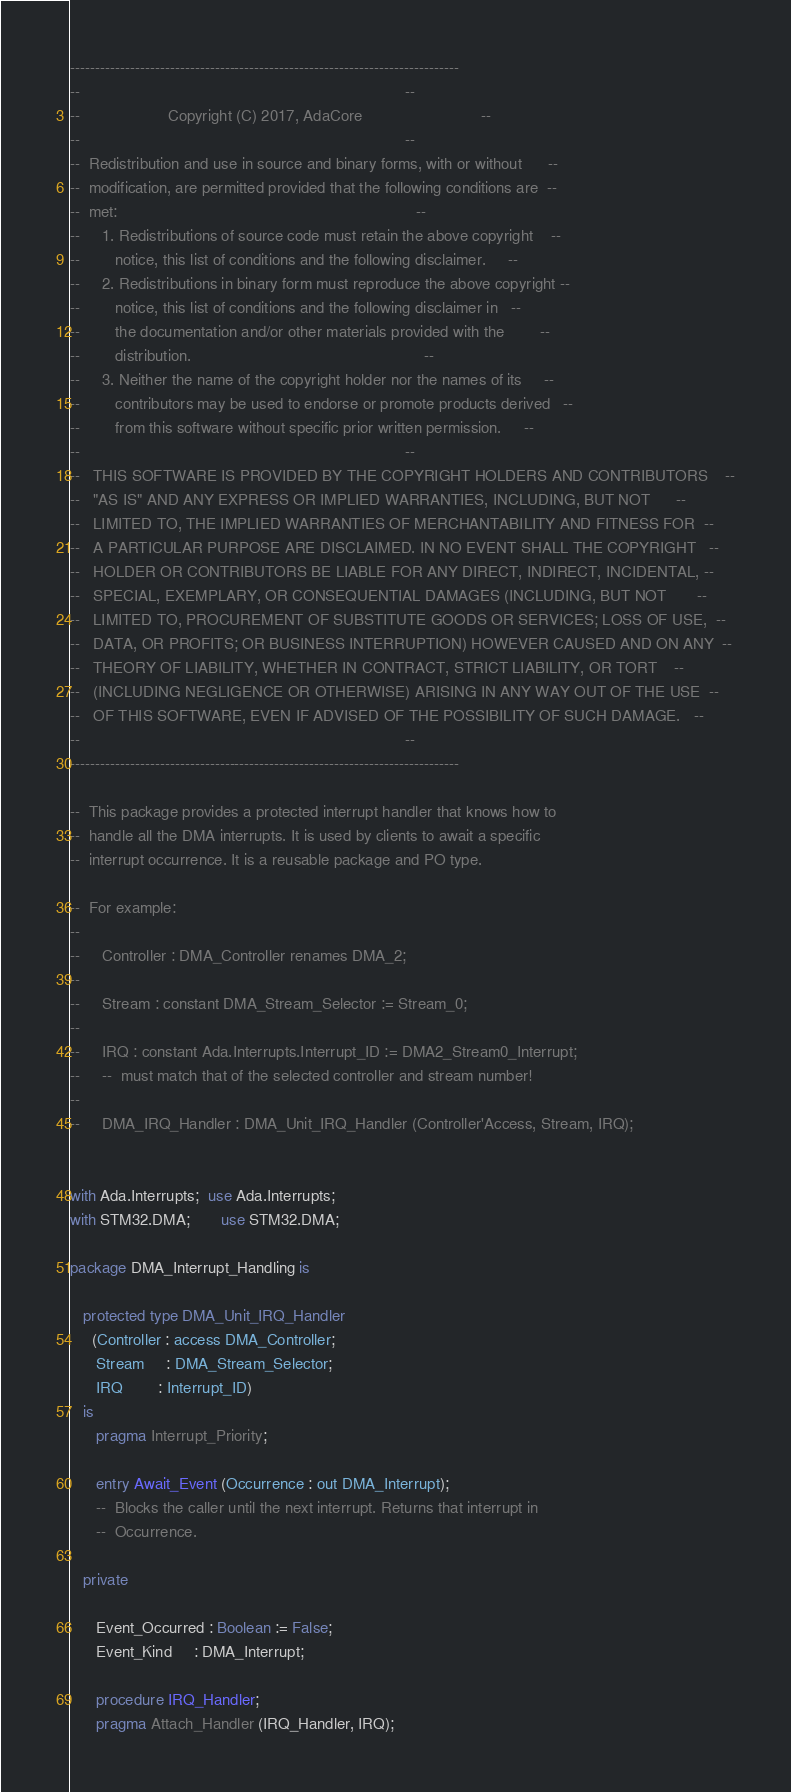<code> <loc_0><loc_0><loc_500><loc_500><_Ada_>------------------------------------------------------------------------------
--                                                                          --
--                    Copyright (C) 2017, AdaCore                           --
--                                                                          --
--  Redistribution and use in source and binary forms, with or without      --
--  modification, are permitted provided that the following conditions are  --
--  met:                                                                    --
--     1. Redistributions of source code must retain the above copyright    --
--        notice, this list of conditions and the following disclaimer.     --
--     2. Redistributions in binary form must reproduce the above copyright --
--        notice, this list of conditions and the following disclaimer in   --
--        the documentation and/or other materials provided with the        --
--        distribution.                                                     --
--     3. Neither the name of the copyright holder nor the names of its     --
--        contributors may be used to endorse or promote products derived   --
--        from this software without specific prior written permission.     --
--                                                                          --
--   THIS SOFTWARE IS PROVIDED BY THE COPYRIGHT HOLDERS AND CONTRIBUTORS    --
--   "AS IS" AND ANY EXPRESS OR IMPLIED WARRANTIES, INCLUDING, BUT NOT      --
--   LIMITED TO, THE IMPLIED WARRANTIES OF MERCHANTABILITY AND FITNESS FOR  --
--   A PARTICULAR PURPOSE ARE DISCLAIMED. IN NO EVENT SHALL THE COPYRIGHT   --
--   HOLDER OR CONTRIBUTORS BE LIABLE FOR ANY DIRECT, INDIRECT, INCIDENTAL, --
--   SPECIAL, EXEMPLARY, OR CONSEQUENTIAL DAMAGES (INCLUDING, BUT NOT       --
--   LIMITED TO, PROCUREMENT OF SUBSTITUTE GOODS OR SERVICES; LOSS OF USE,  --
--   DATA, OR PROFITS; OR BUSINESS INTERRUPTION) HOWEVER CAUSED AND ON ANY  --
--   THEORY OF LIABILITY, WHETHER IN CONTRACT, STRICT LIABILITY, OR TORT    --
--   (INCLUDING NEGLIGENCE OR OTHERWISE) ARISING IN ANY WAY OUT OF THE USE  --
--   OF THIS SOFTWARE, EVEN IF ADVISED OF THE POSSIBILITY OF SUCH DAMAGE.   --
--                                                                          --
------------------------------------------------------------------------------

--  This package provides a protected interrupt handler that knows how to
--  handle all the DMA interrupts. It is used by clients to await a specific
--  interrupt occurrence. It is a reusable package and PO type.

--  For example:
--
--     Controller : DMA_Controller renames DMA_2;
--
--     Stream : constant DMA_Stream_Selector := Stream_0;
--
--     IRQ : constant Ada.Interrupts.Interrupt_ID := DMA2_Stream0_Interrupt;
--     --  must match that of the selected controller and stream number!
--
--     DMA_IRQ_Handler : DMA_Unit_IRQ_Handler (Controller'Access, Stream, IRQ);


with Ada.Interrupts;  use Ada.Interrupts;
with STM32.DMA;       use STM32.DMA;

package DMA_Interrupt_Handling is

   protected type DMA_Unit_IRQ_Handler
     (Controller : access DMA_Controller;
      Stream     : DMA_Stream_Selector;
      IRQ        : Interrupt_ID)
   is
      pragma Interrupt_Priority;

      entry Await_Event (Occurrence : out DMA_Interrupt);
      --  Blocks the caller until the next interrupt. Returns that interrupt in
      --  Occurrence.

   private

      Event_Occurred : Boolean := False;
      Event_Kind     : DMA_Interrupt;

      procedure IRQ_Handler;
      pragma Attach_Handler (IRQ_Handler, IRQ);</code> 